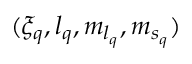Convert formula to latex. <formula><loc_0><loc_0><loc_500><loc_500>( { \xi } _ { q } , { l } _ { q } , { m } _ { { l } _ { q } } , { m } _ { { s } _ { q } } )</formula> 